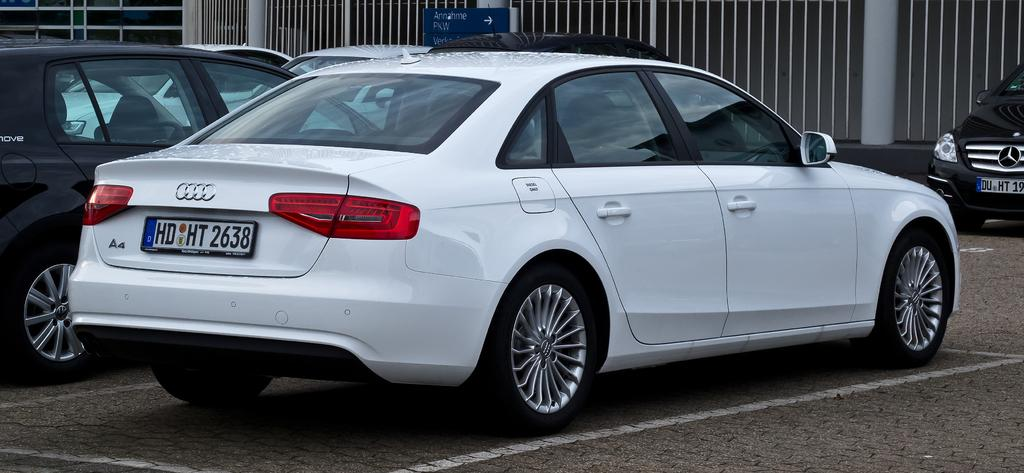What type of vehicles can be seen in the image? There are cars in the image. What is located at the top of the image? There are grills at the top of the image. What type of canvas is being used by the person in the image? There is no canvas or person present in the image; it only features cars and grills. 